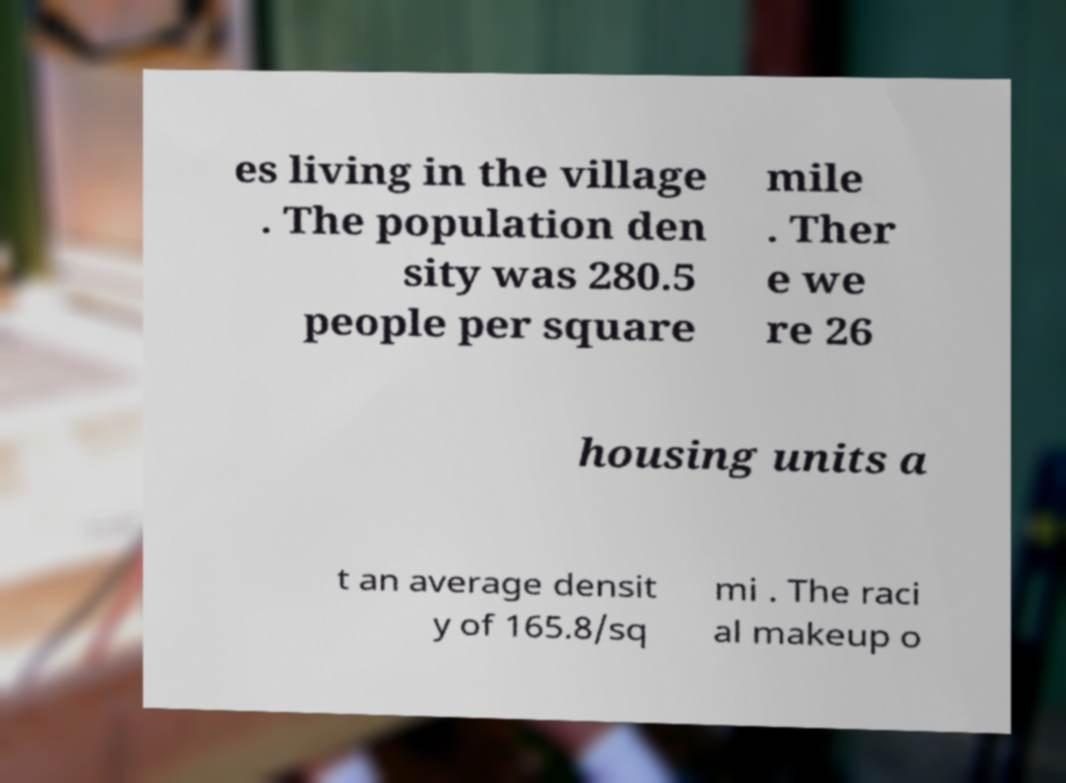Could you assist in decoding the text presented in this image and type it out clearly? es living in the village . The population den sity was 280.5 people per square mile . Ther e we re 26 housing units a t an average densit y of 165.8/sq mi . The raci al makeup o 